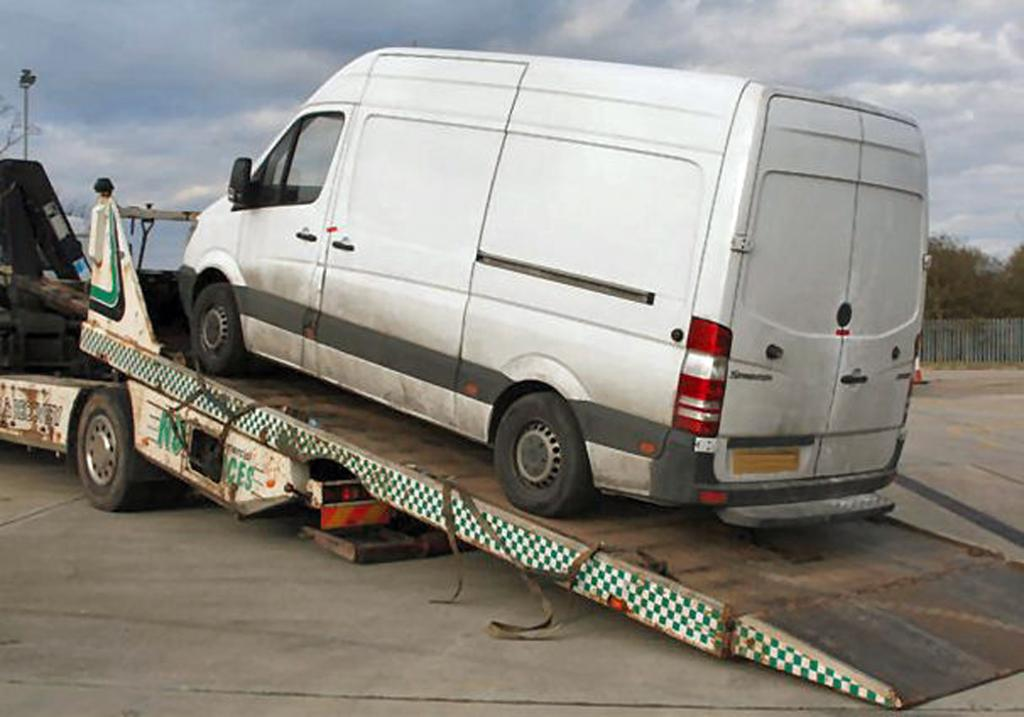What is being transported on the truck in the image? There is a vehicle on a truck in the image. What type of natural environment can be seen in the image? There are trees visible in the image. What safety feature is present in the image? There is railing in the image. What is visible above the ground in the image? The sky is visible in the image. What type of iron is being used for punishment in the image? There is no iron or punishment present in the image. What observation can be made about the vehicle's condition in the image? The image does not provide any information about the vehicle's condition, only that it is being transported on a truck. 